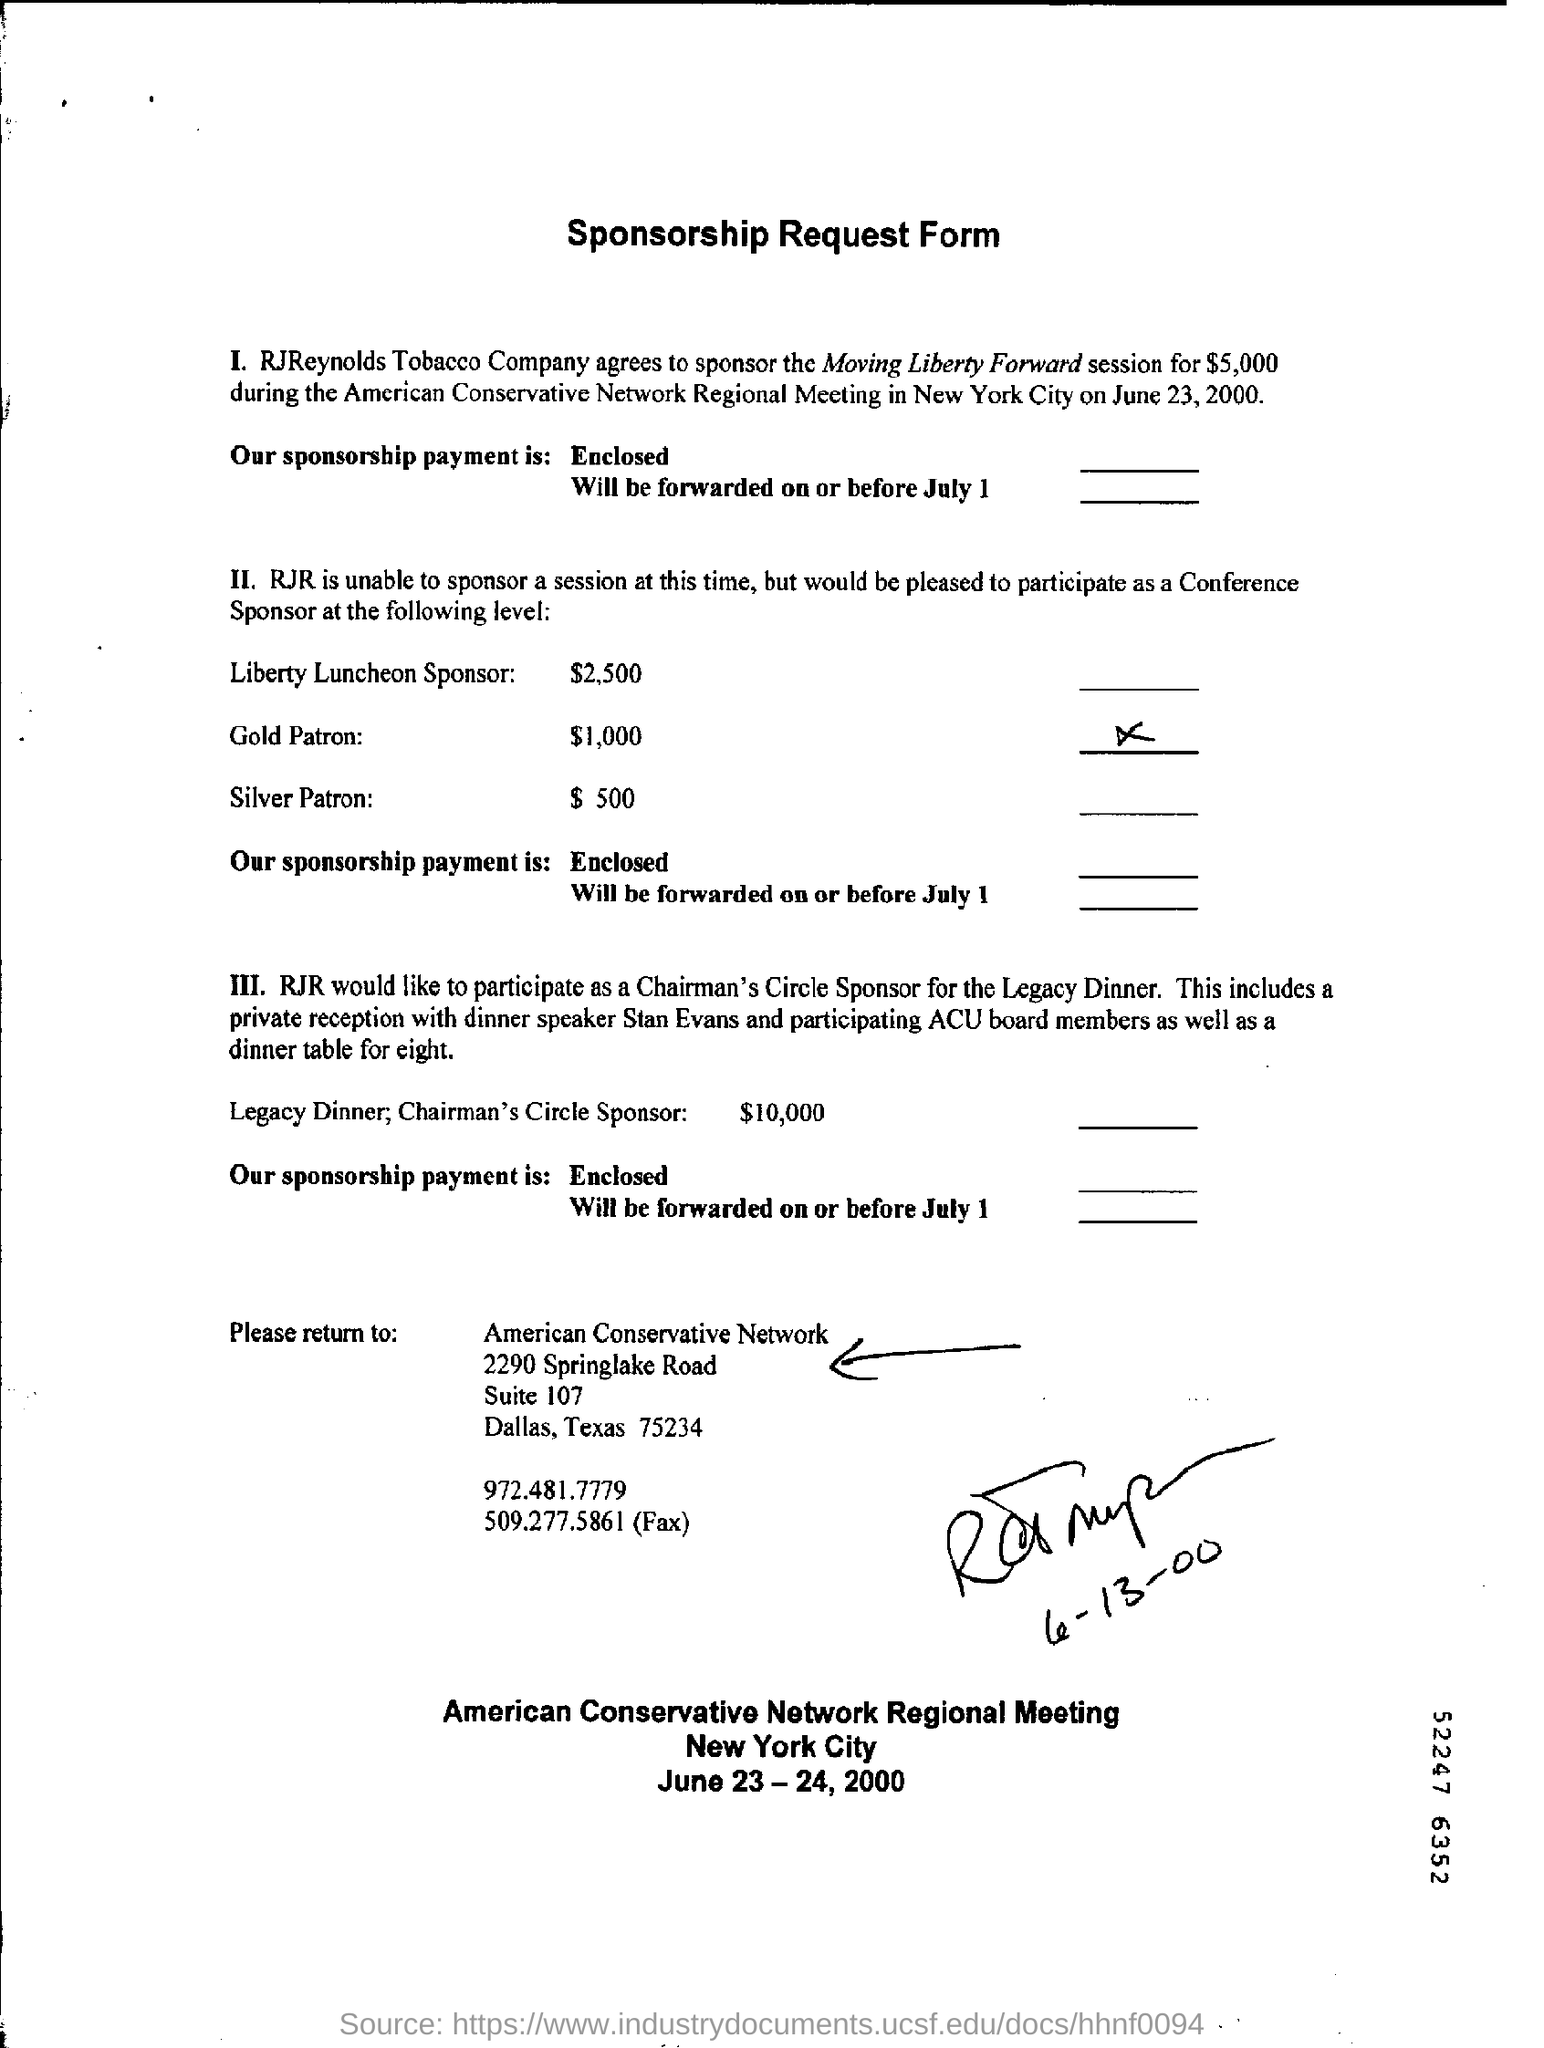Outline some significant characteristics in this image. The American Conservative Regional Meeting takes place in New York City. RJ Reynolds Tobacco Company agreed to sponsor the Moving Liberty Forward session. The American Conservative Network Regional Meeting was held on June 23, 2000. The fax number for American Conservative Network is 509.277.5861. The RJReynolds Tobacco Company agreed to sponsor the Moving Liberty Forward session for a total of $5,000. 